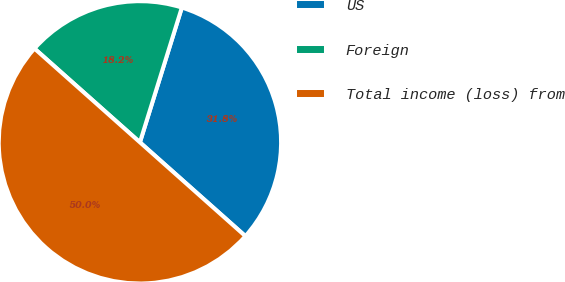Convert chart. <chart><loc_0><loc_0><loc_500><loc_500><pie_chart><fcel>US<fcel>Foreign<fcel>Total income (loss) from<nl><fcel>31.77%<fcel>18.23%<fcel>50.0%<nl></chart> 